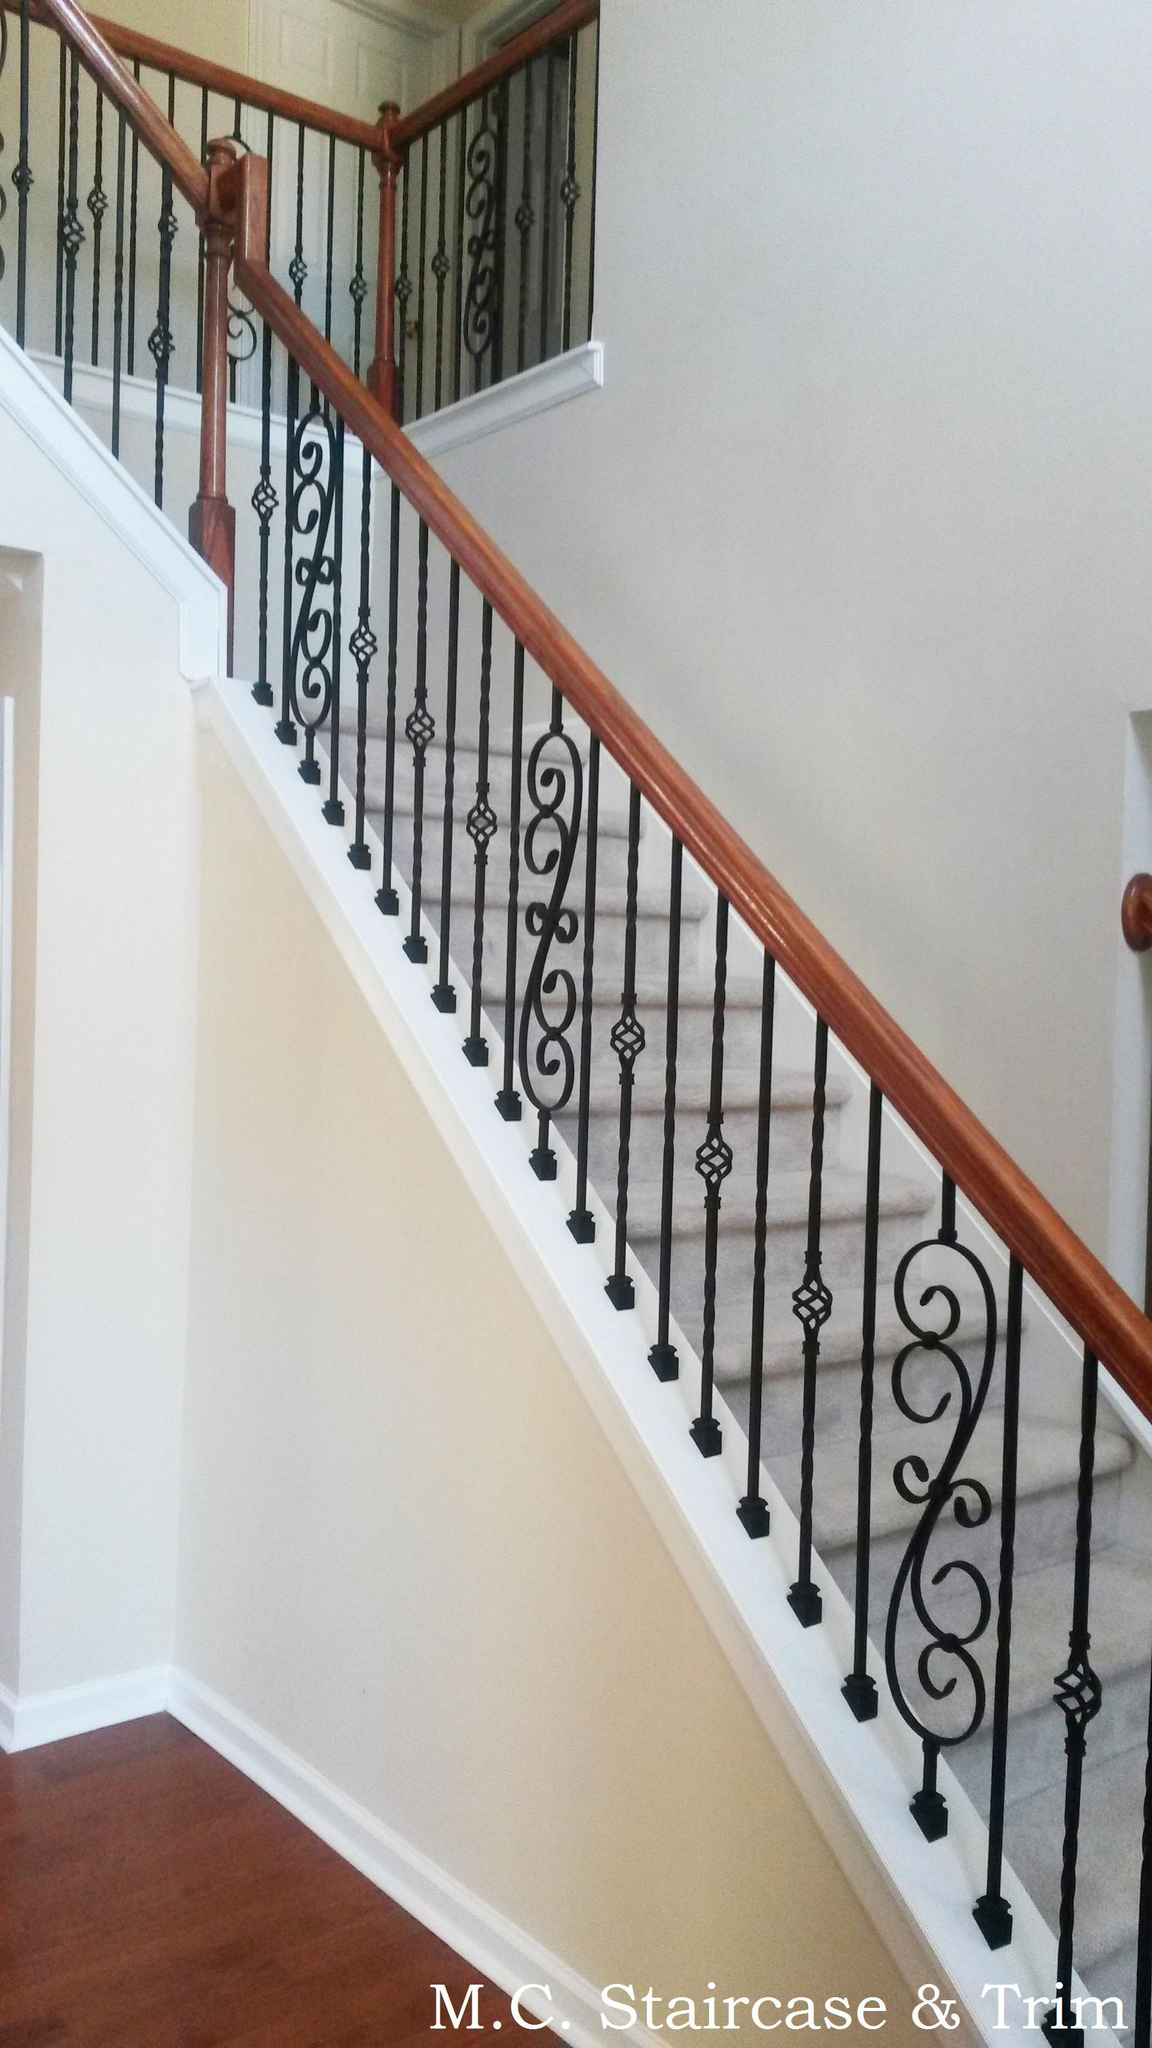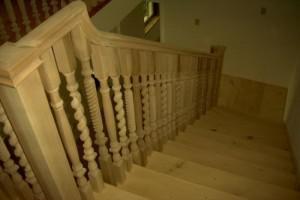The first image is the image on the left, the second image is the image on the right. Assess this claim about the two images: "The left image shows a staircase banister with dark wrought iron bars, and the right image shows a staircase with white spindles on its banister.". Correct or not? Answer yes or no. Yes. 